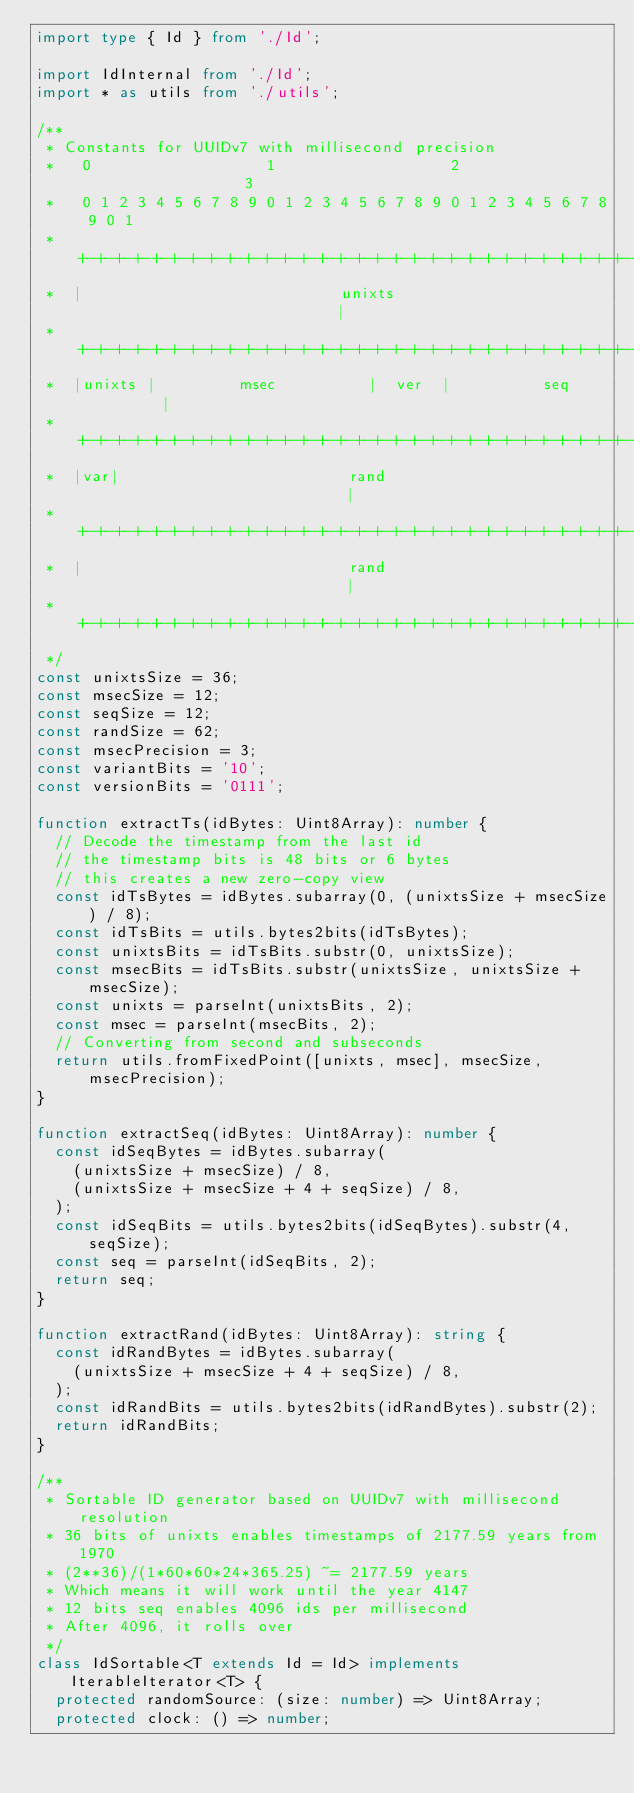Convert code to text. <code><loc_0><loc_0><loc_500><loc_500><_TypeScript_>import type { Id } from './Id';

import IdInternal from './Id';
import * as utils from './utils';

/**
 * Constants for UUIDv7 with millisecond precision
 *   0                   1                   2                   3
 *   0 1 2 3 4 5 6 7 8 9 0 1 2 3 4 5 6 7 8 9 0 1 2 3 4 5 6 7 8 9 0 1
 *  +-+-+-+-+-+-+-+-+-+-+-+-+-+-+-+-+-+-+-+-+-+-+-+-+-+-+-+-+-+-+-+-+
 *  |                            unixts                             |
 *  +-+-+-+-+-+-+-+-+-+-+-+-+-+-+-+-+-+-+-+-+-+-+-+-+-+-+-+-+-+-+-+-+
 *  |unixts |         msec          |  ver  |          seq          |
 *  +-+-+-+-+-+-+-+-+-+-+-+-+-+-+-+-+-+-+-+-+-+-+-+-+-+-+-+-+-+-+-+-+
 *  |var|                         rand                              |
 *  +-+-+-+-+-+-+-+-+-+-+-+-+-+-+-+-+-+-+-+-+-+-+-+-+-+-+-+-+-+-+-+-+
 *  |                             rand                              |
 *  +-+-+-+-+-+-+-+-+-+-+-+-+-+-+-+-+-+-+-+-+-+-+-+-+-+-+-+-+-+-+-+-+
 */
const unixtsSize = 36;
const msecSize = 12;
const seqSize = 12;
const randSize = 62;
const msecPrecision = 3;
const variantBits = '10';
const versionBits = '0111';

function extractTs(idBytes: Uint8Array): number {
  // Decode the timestamp from the last id
  // the timestamp bits is 48 bits or 6 bytes
  // this creates a new zero-copy view
  const idTsBytes = idBytes.subarray(0, (unixtsSize + msecSize) / 8);
  const idTsBits = utils.bytes2bits(idTsBytes);
  const unixtsBits = idTsBits.substr(0, unixtsSize);
  const msecBits = idTsBits.substr(unixtsSize, unixtsSize + msecSize);
  const unixts = parseInt(unixtsBits, 2);
  const msec = parseInt(msecBits, 2);
  // Converting from second and subseconds
  return utils.fromFixedPoint([unixts, msec], msecSize, msecPrecision);
}

function extractSeq(idBytes: Uint8Array): number {
  const idSeqBytes = idBytes.subarray(
    (unixtsSize + msecSize) / 8,
    (unixtsSize + msecSize + 4 + seqSize) / 8,
  );
  const idSeqBits = utils.bytes2bits(idSeqBytes).substr(4, seqSize);
  const seq = parseInt(idSeqBits, 2);
  return seq;
}

function extractRand(idBytes: Uint8Array): string {
  const idRandBytes = idBytes.subarray(
    (unixtsSize + msecSize + 4 + seqSize) / 8,
  );
  const idRandBits = utils.bytes2bits(idRandBytes).substr(2);
  return idRandBits;
}

/**
 * Sortable ID generator based on UUIDv7 with millisecond resolution
 * 36 bits of unixts enables timestamps of 2177.59 years from 1970
 * (2**36)/(1*60*60*24*365.25) ~= 2177.59 years
 * Which means it will work until the year 4147
 * 12 bits seq enables 4096 ids per millisecond
 * After 4096, it rolls over
 */
class IdSortable<T extends Id = Id> implements IterableIterator<T> {
  protected randomSource: (size: number) => Uint8Array;
  protected clock: () => number;</code> 